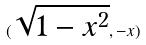<formula> <loc_0><loc_0><loc_500><loc_500>( \sqrt { 1 - x ^ { 2 } } , - x )</formula> 